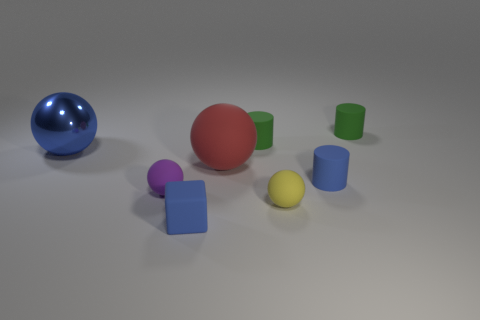Add 1 tiny cylinders. How many objects exist? 9 Subtract all cylinders. How many objects are left? 5 Subtract 0 brown cylinders. How many objects are left? 8 Subtract all tiny matte cylinders. Subtract all green rubber cylinders. How many objects are left? 3 Add 8 green matte cylinders. How many green matte cylinders are left? 10 Add 3 purple rubber things. How many purple rubber things exist? 4 